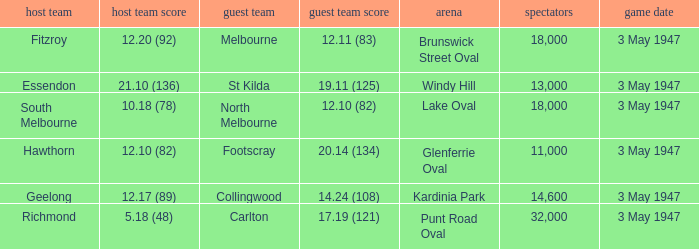In the game where the away team score is 17.19 (121), who was the away team? Carlton. 